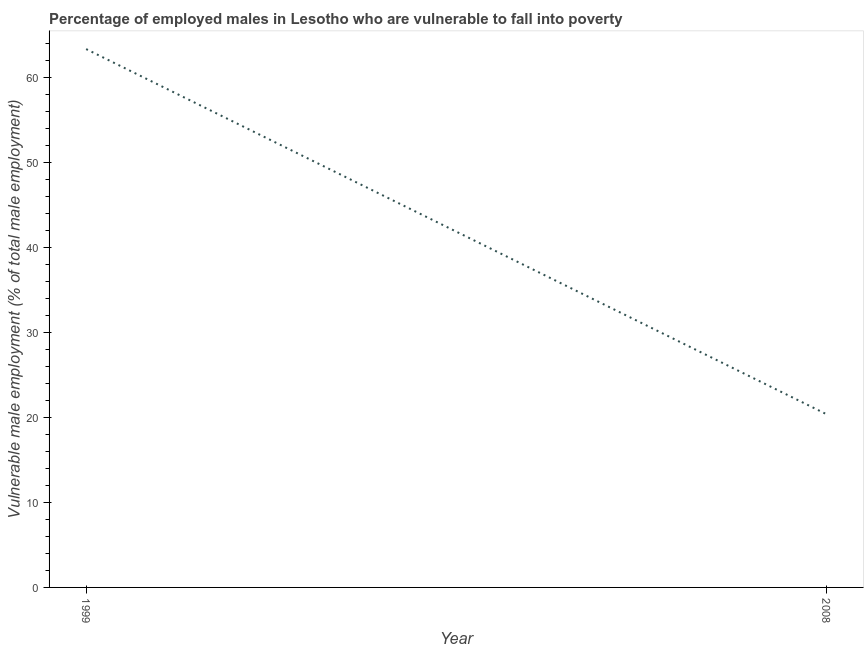What is the percentage of employed males who are vulnerable to fall into poverty in 1999?
Provide a short and direct response. 63.4. Across all years, what is the maximum percentage of employed males who are vulnerable to fall into poverty?
Ensure brevity in your answer.  63.4. Across all years, what is the minimum percentage of employed males who are vulnerable to fall into poverty?
Make the answer very short. 20.4. In which year was the percentage of employed males who are vulnerable to fall into poverty maximum?
Keep it short and to the point. 1999. In which year was the percentage of employed males who are vulnerable to fall into poverty minimum?
Make the answer very short. 2008. What is the sum of the percentage of employed males who are vulnerable to fall into poverty?
Ensure brevity in your answer.  83.8. What is the difference between the percentage of employed males who are vulnerable to fall into poverty in 1999 and 2008?
Give a very brief answer. 43. What is the average percentage of employed males who are vulnerable to fall into poverty per year?
Ensure brevity in your answer.  41.9. What is the median percentage of employed males who are vulnerable to fall into poverty?
Give a very brief answer. 41.9. In how many years, is the percentage of employed males who are vulnerable to fall into poverty greater than 34 %?
Keep it short and to the point. 1. What is the ratio of the percentage of employed males who are vulnerable to fall into poverty in 1999 to that in 2008?
Your answer should be very brief. 3.11. How many years are there in the graph?
Your response must be concise. 2. What is the difference between two consecutive major ticks on the Y-axis?
Provide a short and direct response. 10. Are the values on the major ticks of Y-axis written in scientific E-notation?
Make the answer very short. No. Does the graph contain any zero values?
Your response must be concise. No. Does the graph contain grids?
Give a very brief answer. No. What is the title of the graph?
Make the answer very short. Percentage of employed males in Lesotho who are vulnerable to fall into poverty. What is the label or title of the Y-axis?
Your response must be concise. Vulnerable male employment (% of total male employment). What is the Vulnerable male employment (% of total male employment) of 1999?
Provide a succinct answer. 63.4. What is the Vulnerable male employment (% of total male employment) of 2008?
Give a very brief answer. 20.4. What is the ratio of the Vulnerable male employment (% of total male employment) in 1999 to that in 2008?
Make the answer very short. 3.11. 